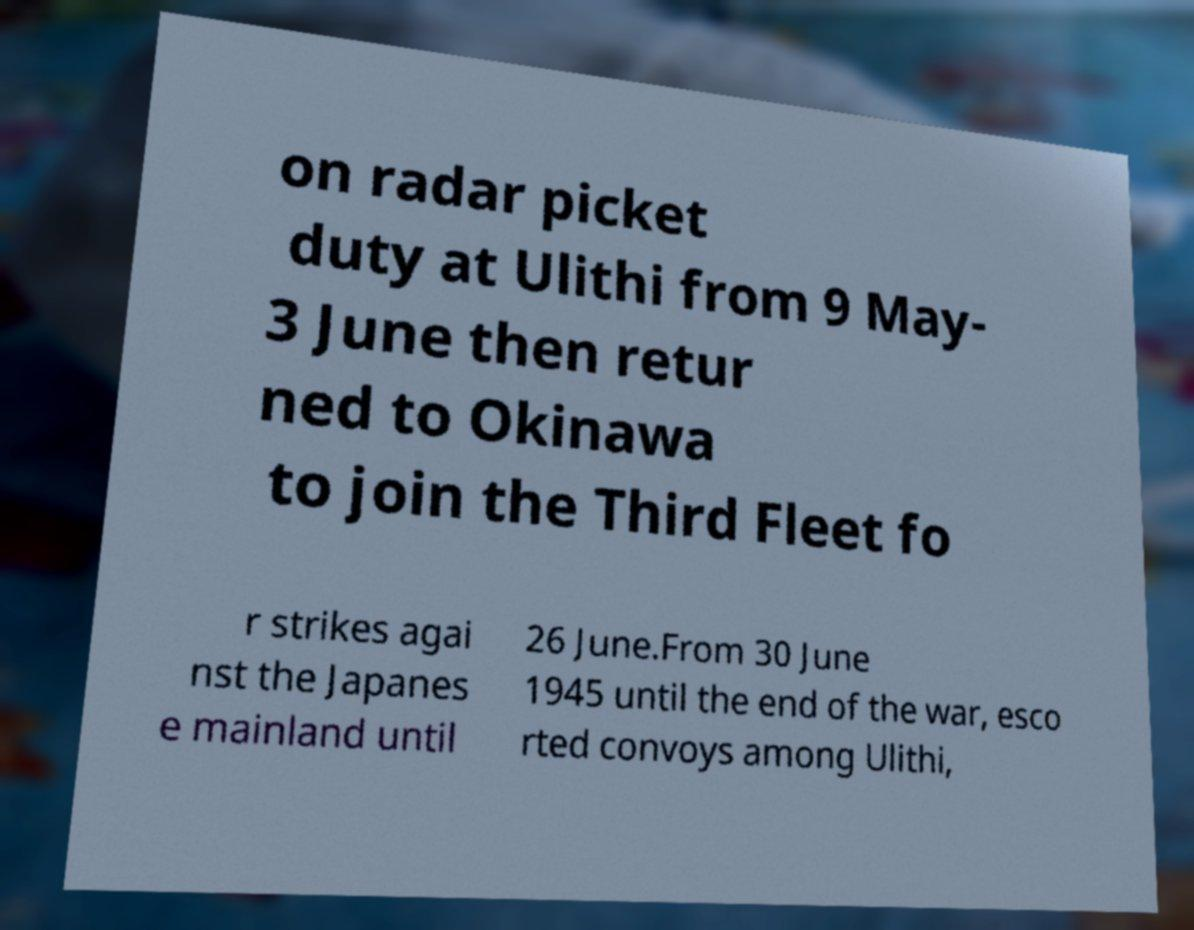Please read and relay the text visible in this image. What does it say? on radar picket duty at Ulithi from 9 May- 3 June then retur ned to Okinawa to join the Third Fleet fo r strikes agai nst the Japanes e mainland until 26 June.From 30 June 1945 until the end of the war, esco rted convoys among Ulithi, 